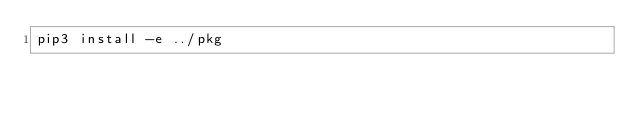<code> <loc_0><loc_0><loc_500><loc_500><_Bash_>pip3 install -e ../pkg</code> 